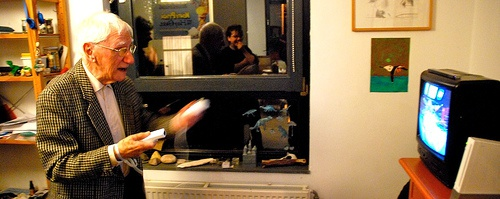Describe the objects in this image and their specific colors. I can see people in maroon, black, olive, tan, and brown tones, tv in maroon, black, white, cyan, and olive tones, people in maroon, black, and olive tones, people in maroon, black, and brown tones, and people in maroon, black, and olive tones in this image. 